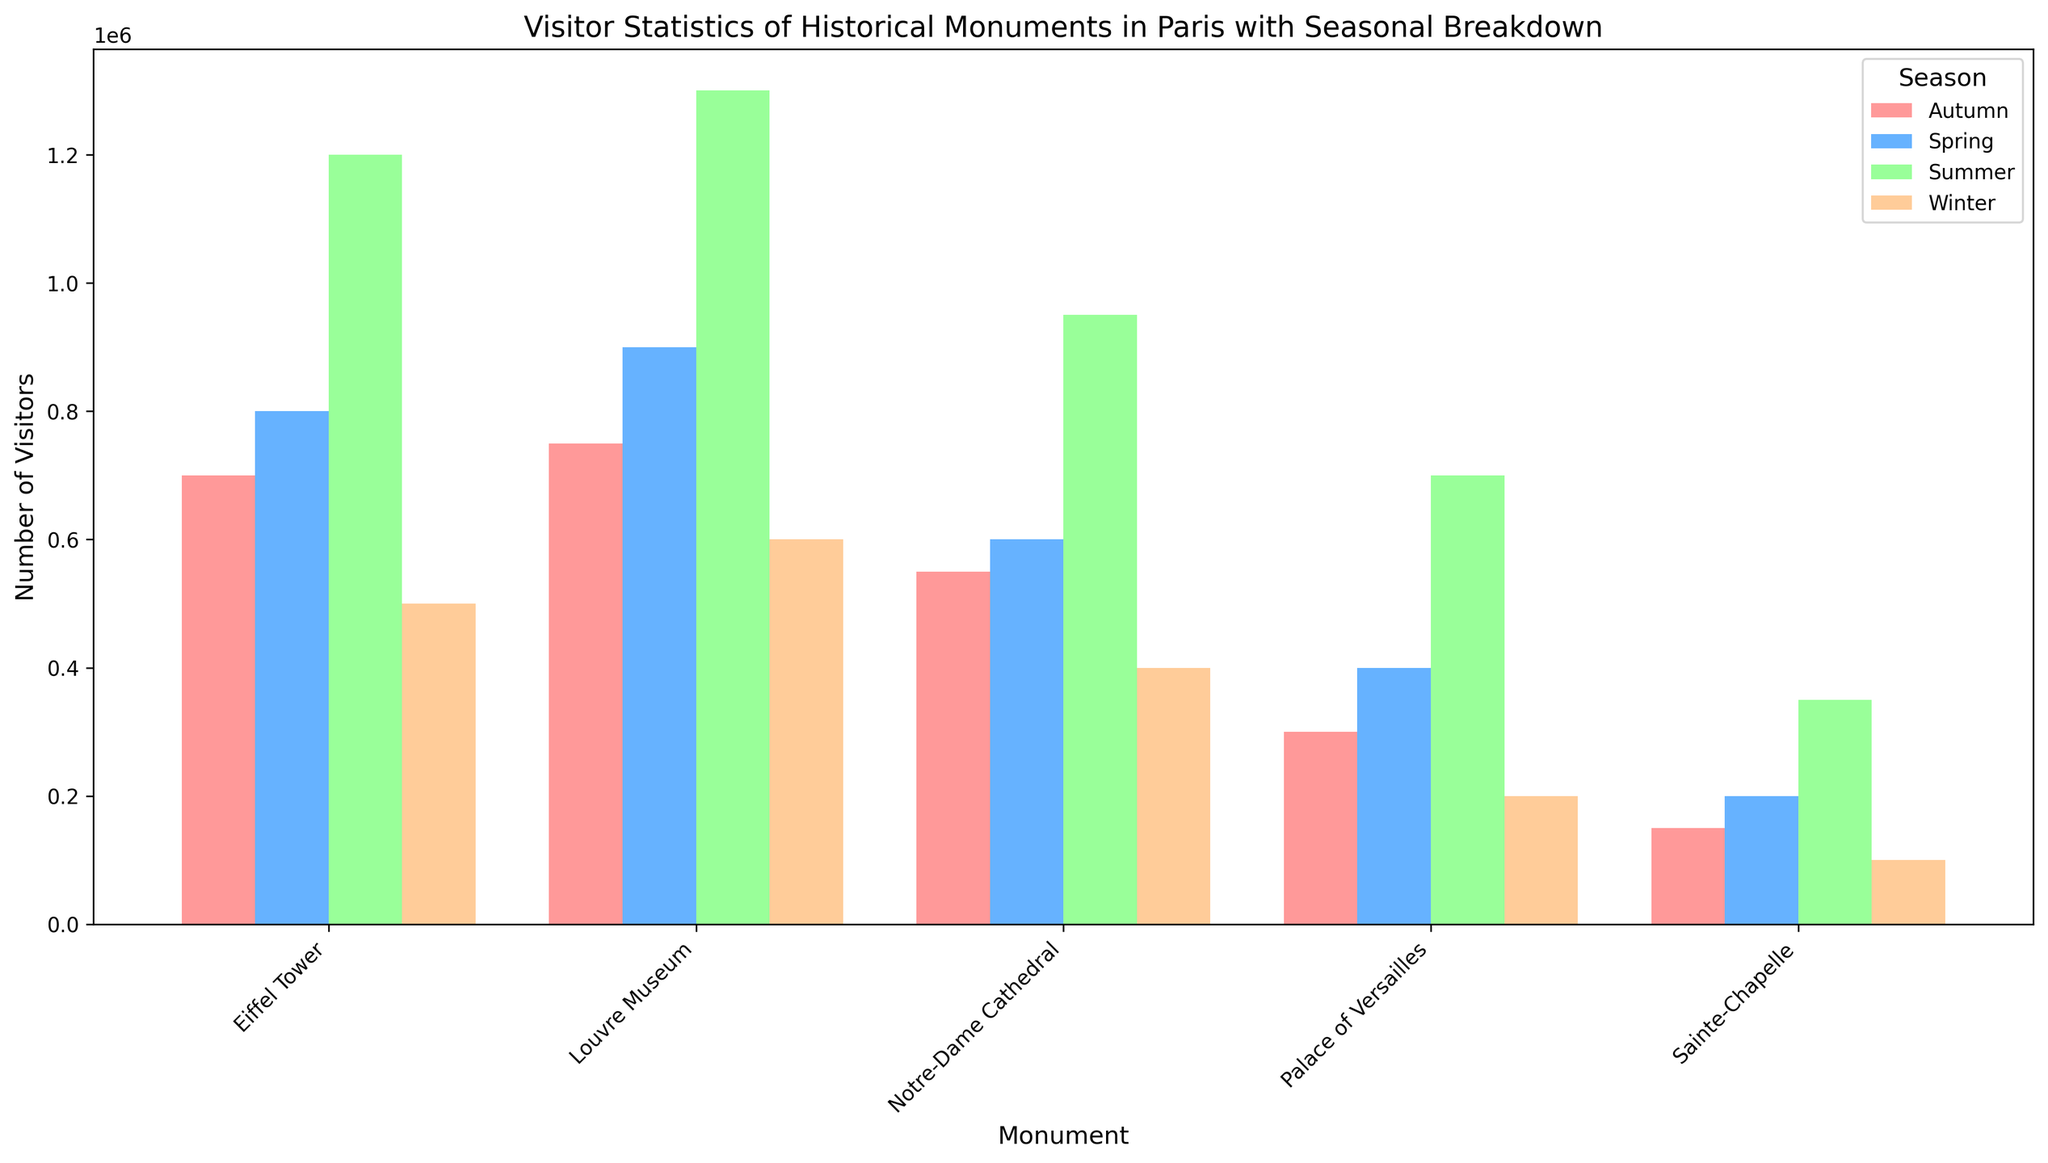What season draws the most visitors to the Eiffel Tower? To determine which season has the highest number of visitors for the Eiffel Tower, look at the individual bars for each season for this monument and compare their heights. The tallest bar corresponds to Summer with 1,200,000 visitors.
Answer: Summer Which historical monument has the least visitors during Winter? To answer this question, identify the bars representing Winter for all monuments and find the shortest one. The shortest bar for Winter corresponds to Sainte-Chapelle with 100,000 visitors.
Answer: Sainte-Chapelle How many more visitors does the Louvre Museum receive in Summer compared to the Palace of Versailles in the same season? Find the number of visitors for both monuments in Summer: Louvre Museum (1,300,000) and Palace of Versailles (700,000). Subtract the visitors for Palace of Versailles from those for the Louvre Museum: 1,300,000 - 700,000 = 600,000.
Answer: 600,000 What's the average number of visitors in Spring across all five monuments? Sum the visitors in Spring for all monuments: Eiffel Tower (800,000), Louvre Museum (900,000), Notre-Dame Cathedral (600,000), Palace of Versailles (400,000), Sainte-Chapelle (200,000). Total = 800,000 + 900,000 + 600,000 + 400,000 + 200,000 = 2,900,000. Divide by the number of monuments (5): 2,900,000 / 5 = 580,000.
Answer: 580,000 Which season has the highest cumulative visitors across all historical monuments? Calculate the total visitors for each season by summing the visitors of all monuments for that season. Winter: 500,000 (Eiffel) + 600,000 (Louvre) + 400,000 (Notre-Dame) + 200,000 (Versailles) + 100,000 (Sainte-Chapelle) = 1,800,000. Spring: 800,000 (Eiffel) + 900,000 (Louvre) + 600,000 (Notre-Dame) + 400,000 (Versailles) + 200,000 (Sainte-Chapelle) = 2,900,000. Summer: 1,200,000 (Eiffel) + 1,300,000 (Louvre) + 950,000 (Notre-Dame) + 700,000 (Versailles) + 350,000 (Sainte-Chapelle) = 4,500,000. Autumn: 700,000 (Eiffel) + 750,000 (Louvre) + 550,000 (Notre-Dame) + 300,000 (Versailles) + 150,000 (Sainte-Chapelle) = 2,450,000. Summer has the highest total at 4,500,000.
Answer: Summer Is there a monument that consistently has more visitors in Winter than in Autumn? Compare the visitors in Winter and Autumn for each monument. Eiffel Tower: (Winter 500,000, Autumn 700,000), Louvre Museum: (Winter 600,000, Autumn 750,000), Notre-Dame Cathedral: (Winter 400,000, Autumn 550,000), Palace of Versailles: (Winter 200,000, Autumn 300,000), Sainte-Chapelle: (Winter 100,000, Autumn 150,000). All monuments have fewer visitors in Winter compared to Autumn.
Answer: No 